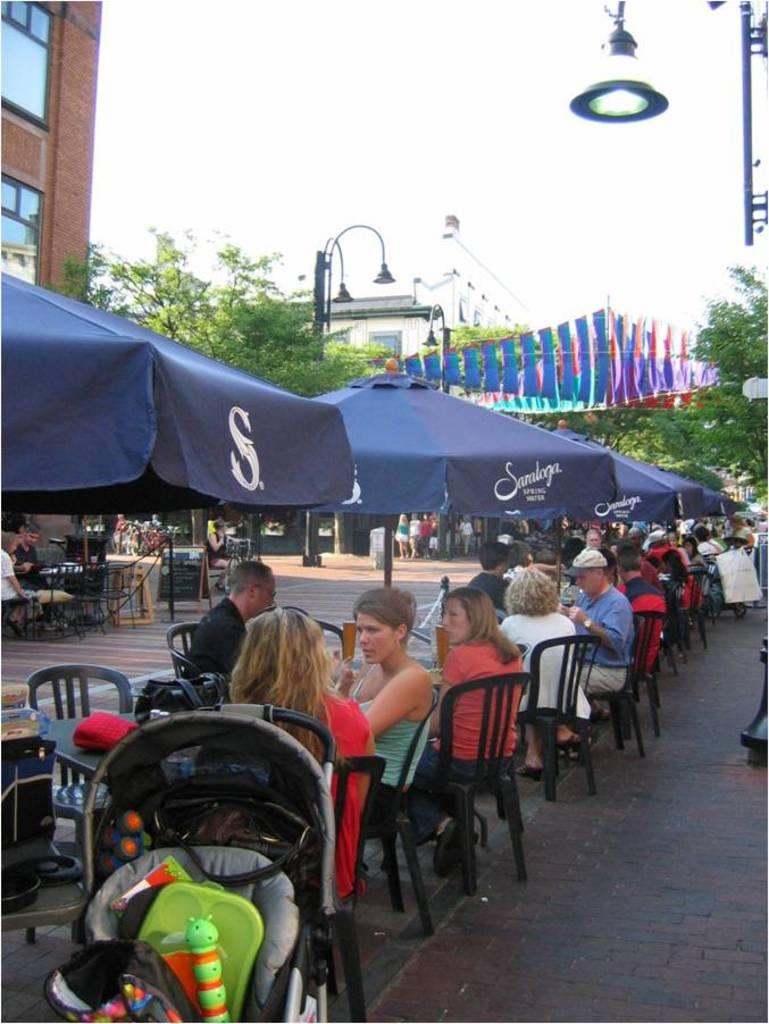What type of natural elements can be seen in the image? There are trees in the image. What part of the natural environment is visible in the image? The sky is visible in the image. What type of man-made structures are present in the image? There are buildings in the image. What type of street furniture is present in the image? A street lamp is present in the image. What type of transportation infrastructure is present in the image? There is a road in the image. What type of furniture is present on the road? Chairs are on the road. What are the people in the image doing? There are people sitting on the chairs. What type of insect is crawling on the chairs in the image? There are no insects present in the image; only chairs, people, trees, buildings, a street lamp, a road, and the sky are visible. 